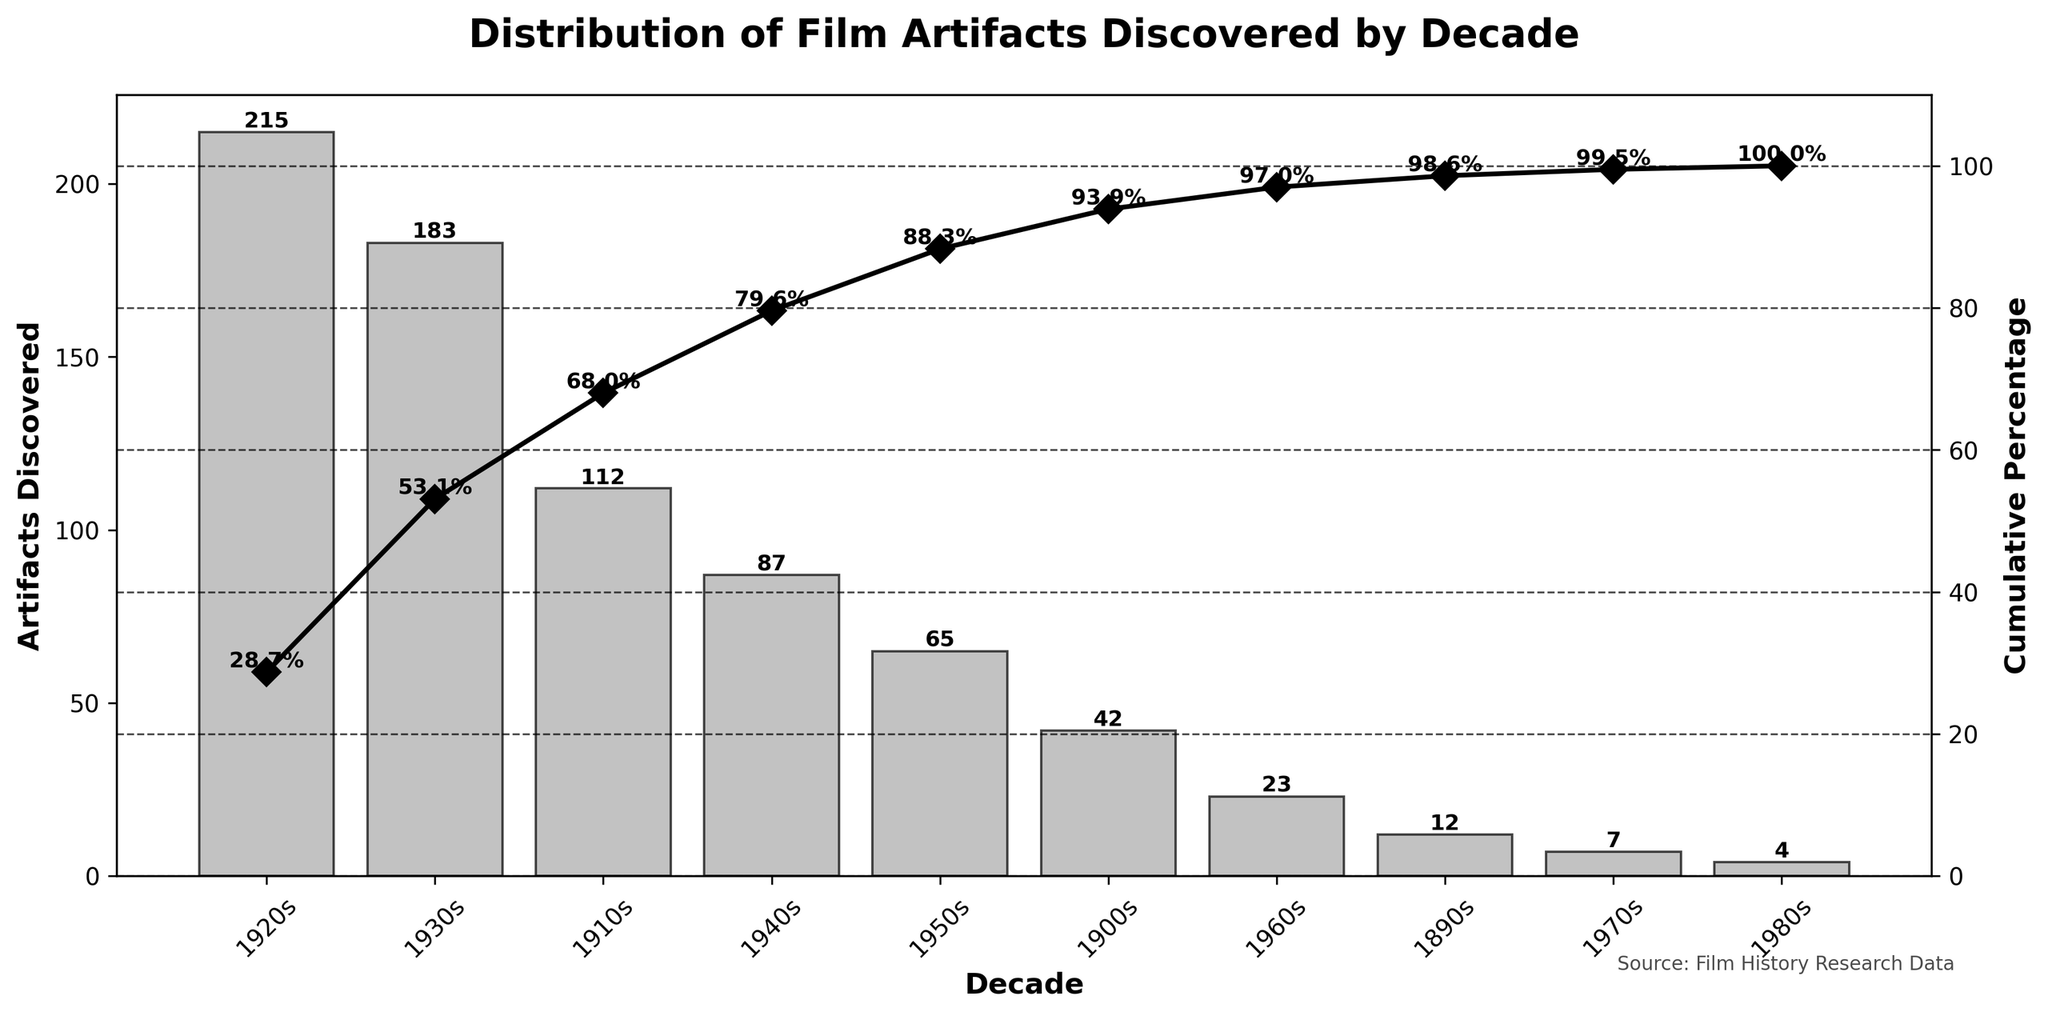What is the title of the chart? The title of the chart is displayed prominently at the top. It reads "Distribution of Film Artifacts Discovered by Decade".
Answer: Distribution of Film Artifacts Discovered by Decade Which decade discovered the highest number of film artifacts? The bar for the 1920s is the tallest, indicating that the highest number of film artifacts was discovered in the 1920s.
Answer: 1920s What is the cumulative percentage of artifacts discovered by the end of the 1930s? The line plot shows cumulative percentages, with the data label for the 1930s indicating a cumulative percentage. This value is 53.1%.
Answer: 53.1% How many artifacts were discovered in the 1960s? The bar representing the 1960s, along with its data label, indicates that 23 artifacts were discovered in that decade.
Answer: 23 What is the total number of artifacts discovered in the 1900s and 1910s combined? Summing the values for the 1900s and 1910s (42 + 112) gives the total number of artifacts discovered in these two decades.
Answer: 154 How does the number of artifacts discovered in the 1940s compare to the 1950s? Comparing the heights of the bars for the 1940s and 1950s, or their data labels, shows that more artifacts were discovered in the 1940s (87) than in the 1950s (65).
Answer: 1940s has more What is the cumulative percentage after including the 1950s data? The chart's line plot and data label for the 1950s show the cumulative percentage after the 1950s, which is 88.3%.
Answer: 88.3% Which decade saw the fewest number of artifacts discovered? The bar for the 1980s is the shortest, denoting the fewest artifacts discovered, with a count of 4.
Answer: 1980s How many artifacts were discovered in total from the 1890s to the 1930s? Adding the values for the 1890s (12), 1900s (42), 1910s (112), 1920s (215), and 1930s (183) gives the total number of artifacts discovered in these decades. 12 + 42 + 112 + 215 + 183 = 564.
Answer: 564 What is the cumulative percentage after the decade with a median number of artifacts discovered? The median value among the total artifacts discovered places the 1940s (87) in the middle. Referring to the cumulative percentage associated with the 1940s, we get 79.6%.
Answer: 79.6% 